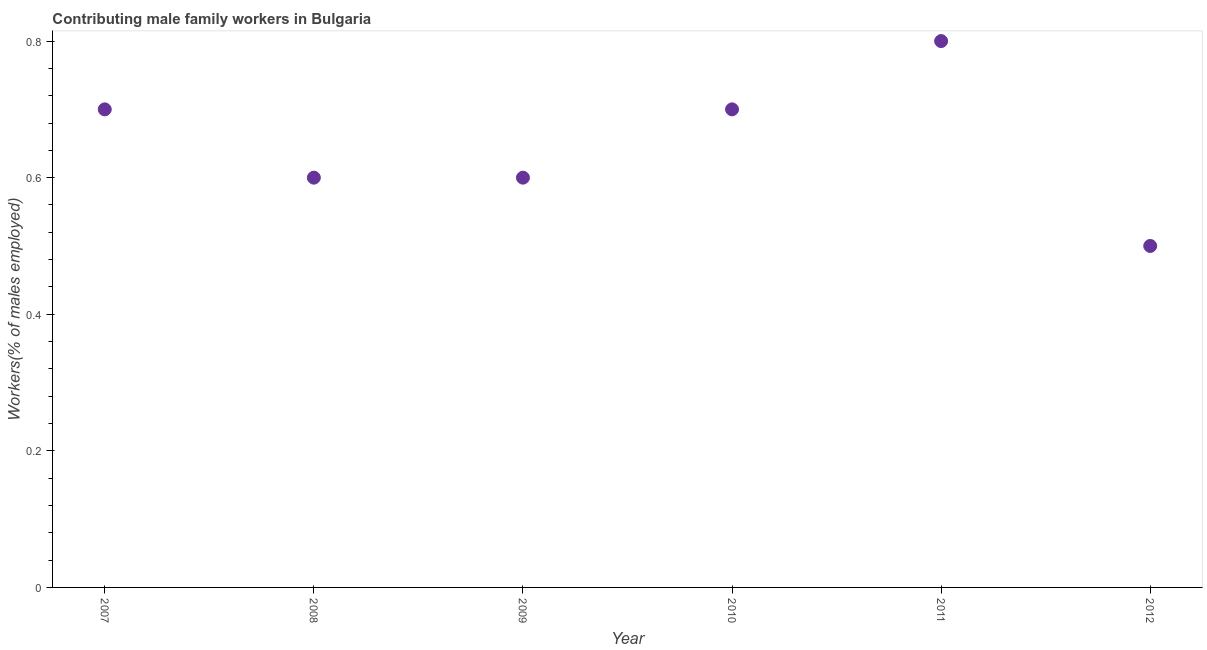What is the contributing male family workers in 2008?
Make the answer very short. 0.6. Across all years, what is the maximum contributing male family workers?
Offer a very short reply. 0.8. Across all years, what is the minimum contributing male family workers?
Offer a very short reply. 0.5. In which year was the contributing male family workers maximum?
Provide a short and direct response. 2011. What is the sum of the contributing male family workers?
Your answer should be very brief. 3.9. What is the difference between the contributing male family workers in 2007 and 2008?
Keep it short and to the point. 0.1. What is the average contributing male family workers per year?
Your answer should be compact. 0.65. What is the median contributing male family workers?
Offer a terse response. 0.65. What is the ratio of the contributing male family workers in 2008 to that in 2011?
Provide a short and direct response. 0.75. Is the contributing male family workers in 2010 less than that in 2012?
Your answer should be very brief. No. Is the difference between the contributing male family workers in 2007 and 2010 greater than the difference between any two years?
Your answer should be compact. No. What is the difference between the highest and the second highest contributing male family workers?
Your answer should be compact. 0.1. Is the sum of the contributing male family workers in 2011 and 2012 greater than the maximum contributing male family workers across all years?
Make the answer very short. Yes. What is the difference between the highest and the lowest contributing male family workers?
Your response must be concise. 0.3. How many dotlines are there?
Your answer should be very brief. 1. Does the graph contain any zero values?
Provide a short and direct response. No. What is the title of the graph?
Provide a succinct answer. Contributing male family workers in Bulgaria. What is the label or title of the X-axis?
Provide a short and direct response. Year. What is the label or title of the Y-axis?
Give a very brief answer. Workers(% of males employed). What is the Workers(% of males employed) in 2007?
Ensure brevity in your answer.  0.7. What is the Workers(% of males employed) in 2008?
Your answer should be compact. 0.6. What is the Workers(% of males employed) in 2009?
Make the answer very short. 0.6. What is the Workers(% of males employed) in 2010?
Your answer should be very brief. 0.7. What is the Workers(% of males employed) in 2011?
Provide a succinct answer. 0.8. What is the Workers(% of males employed) in 2012?
Your response must be concise. 0.5. What is the difference between the Workers(% of males employed) in 2007 and 2008?
Provide a short and direct response. 0.1. What is the difference between the Workers(% of males employed) in 2007 and 2009?
Your answer should be very brief. 0.1. What is the difference between the Workers(% of males employed) in 2007 and 2011?
Provide a short and direct response. -0.1. What is the difference between the Workers(% of males employed) in 2007 and 2012?
Make the answer very short. 0.2. What is the difference between the Workers(% of males employed) in 2008 and 2009?
Offer a terse response. 0. What is the difference between the Workers(% of males employed) in 2009 and 2010?
Your answer should be compact. -0.1. What is the difference between the Workers(% of males employed) in 2009 and 2011?
Keep it short and to the point. -0.2. What is the difference between the Workers(% of males employed) in 2009 and 2012?
Ensure brevity in your answer.  0.1. What is the difference between the Workers(% of males employed) in 2010 and 2011?
Your answer should be compact. -0.1. What is the difference between the Workers(% of males employed) in 2010 and 2012?
Provide a short and direct response. 0.2. What is the difference between the Workers(% of males employed) in 2011 and 2012?
Give a very brief answer. 0.3. What is the ratio of the Workers(% of males employed) in 2007 to that in 2008?
Your answer should be very brief. 1.17. What is the ratio of the Workers(% of males employed) in 2007 to that in 2009?
Provide a short and direct response. 1.17. What is the ratio of the Workers(% of males employed) in 2007 to that in 2010?
Offer a very short reply. 1. What is the ratio of the Workers(% of males employed) in 2008 to that in 2009?
Your response must be concise. 1. What is the ratio of the Workers(% of males employed) in 2008 to that in 2010?
Keep it short and to the point. 0.86. What is the ratio of the Workers(% of males employed) in 2008 to that in 2011?
Ensure brevity in your answer.  0.75. What is the ratio of the Workers(% of males employed) in 2009 to that in 2010?
Your response must be concise. 0.86. What is the ratio of the Workers(% of males employed) in 2011 to that in 2012?
Your response must be concise. 1.6. 